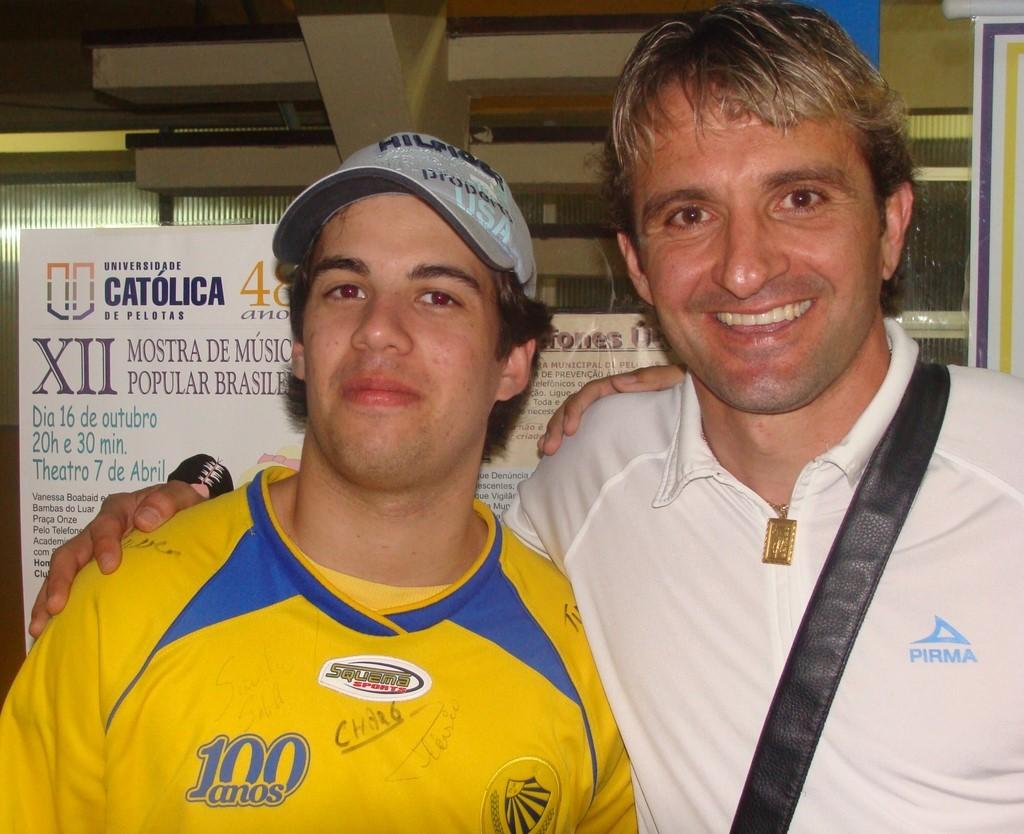<image>
Write a terse but informative summary of the picture. A logo on a yellow shirt represents 100 years. 